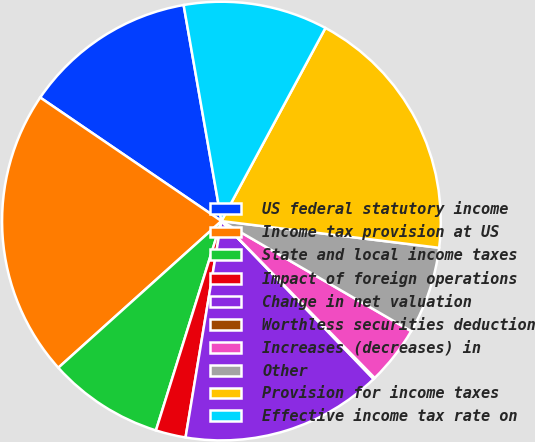<chart> <loc_0><loc_0><loc_500><loc_500><pie_chart><fcel>US federal statutory income<fcel>Income tax provision at US<fcel>State and local income taxes<fcel>Impact of foreign operations<fcel>Change in net valuation<fcel>Worthless securities deduction<fcel>Increases (decreases) in<fcel>Other<fcel>Provision for income taxes<fcel>Effective income tax rate on<nl><fcel>12.72%<fcel>21.18%<fcel>8.52%<fcel>2.21%<fcel>14.82%<fcel>0.11%<fcel>4.32%<fcel>6.42%<fcel>19.08%<fcel>10.62%<nl></chart> 